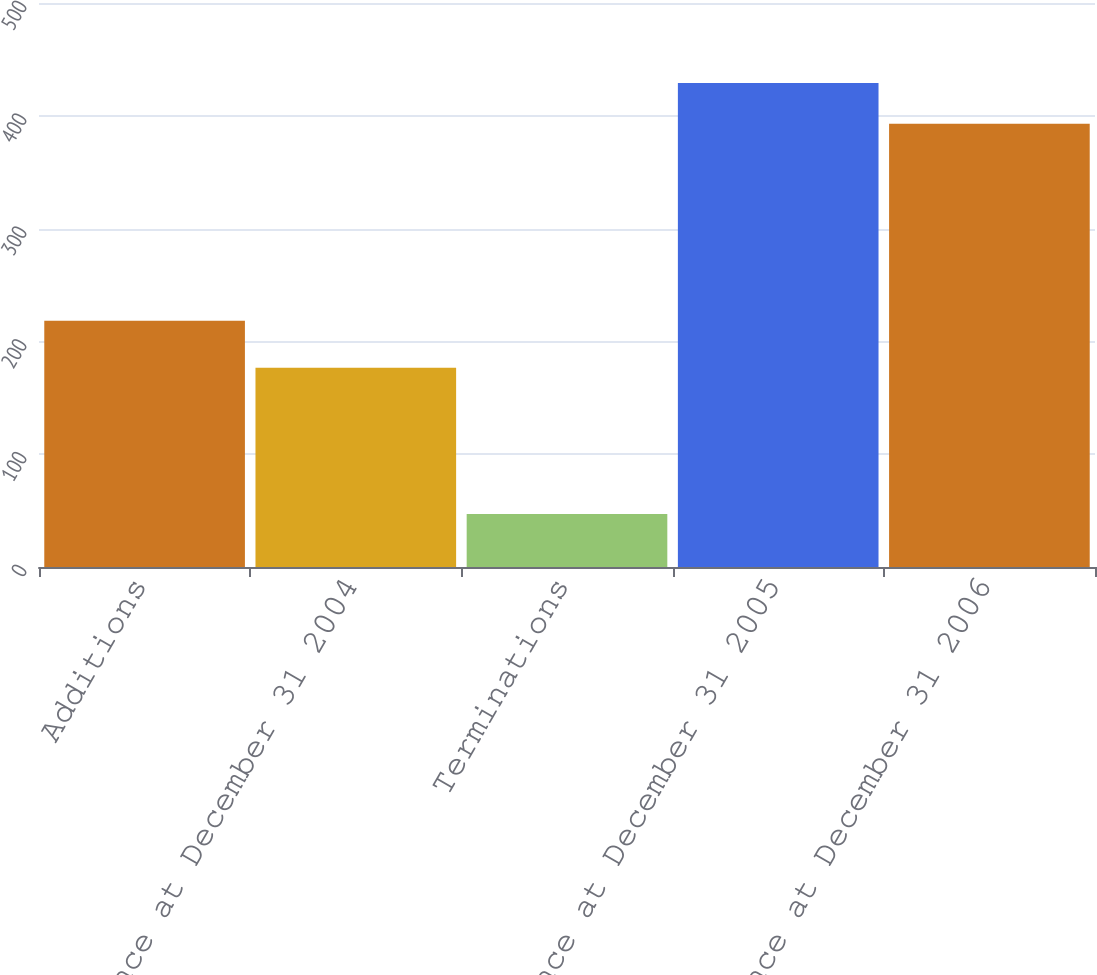Convert chart. <chart><loc_0><loc_0><loc_500><loc_500><bar_chart><fcel>Additions<fcel>Balance at December 31 2004<fcel>Terminations<fcel>Balance at December 31 2005<fcel>Balance at December 31 2006<nl><fcel>218.2<fcel>176.6<fcel>46.9<fcel>429.02<fcel>392.9<nl></chart> 